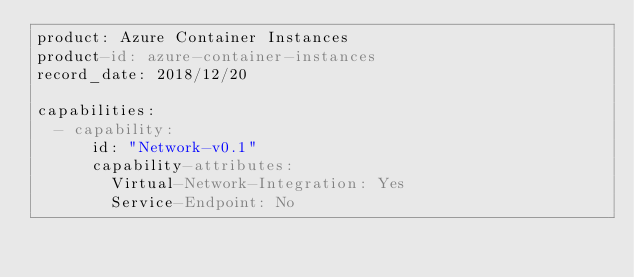<code> <loc_0><loc_0><loc_500><loc_500><_YAML_>product: Azure Container Instances
product-id: azure-container-instances
record_date: 2018/12/20

capabilities:
  - capability:
      id: "Network-v0.1"
      capability-attributes:
        Virtual-Network-Integration: Yes
        Service-Endpoint: No</code> 